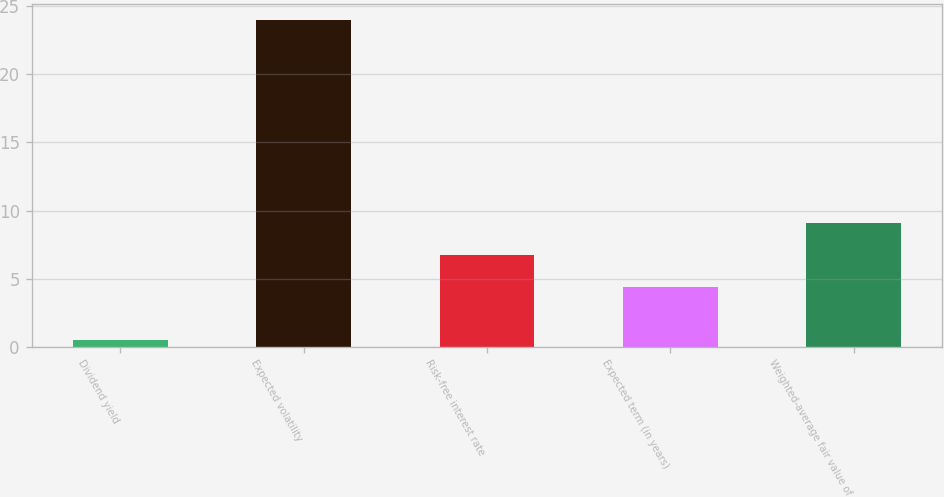Convert chart to OTSL. <chart><loc_0><loc_0><loc_500><loc_500><bar_chart><fcel>Dividend yield<fcel>Expected volatility<fcel>Risk-free interest rate<fcel>Expected term (in years)<fcel>Weighted-average fair value of<nl><fcel>0.5<fcel>24<fcel>6.75<fcel>4.4<fcel>9.1<nl></chart> 